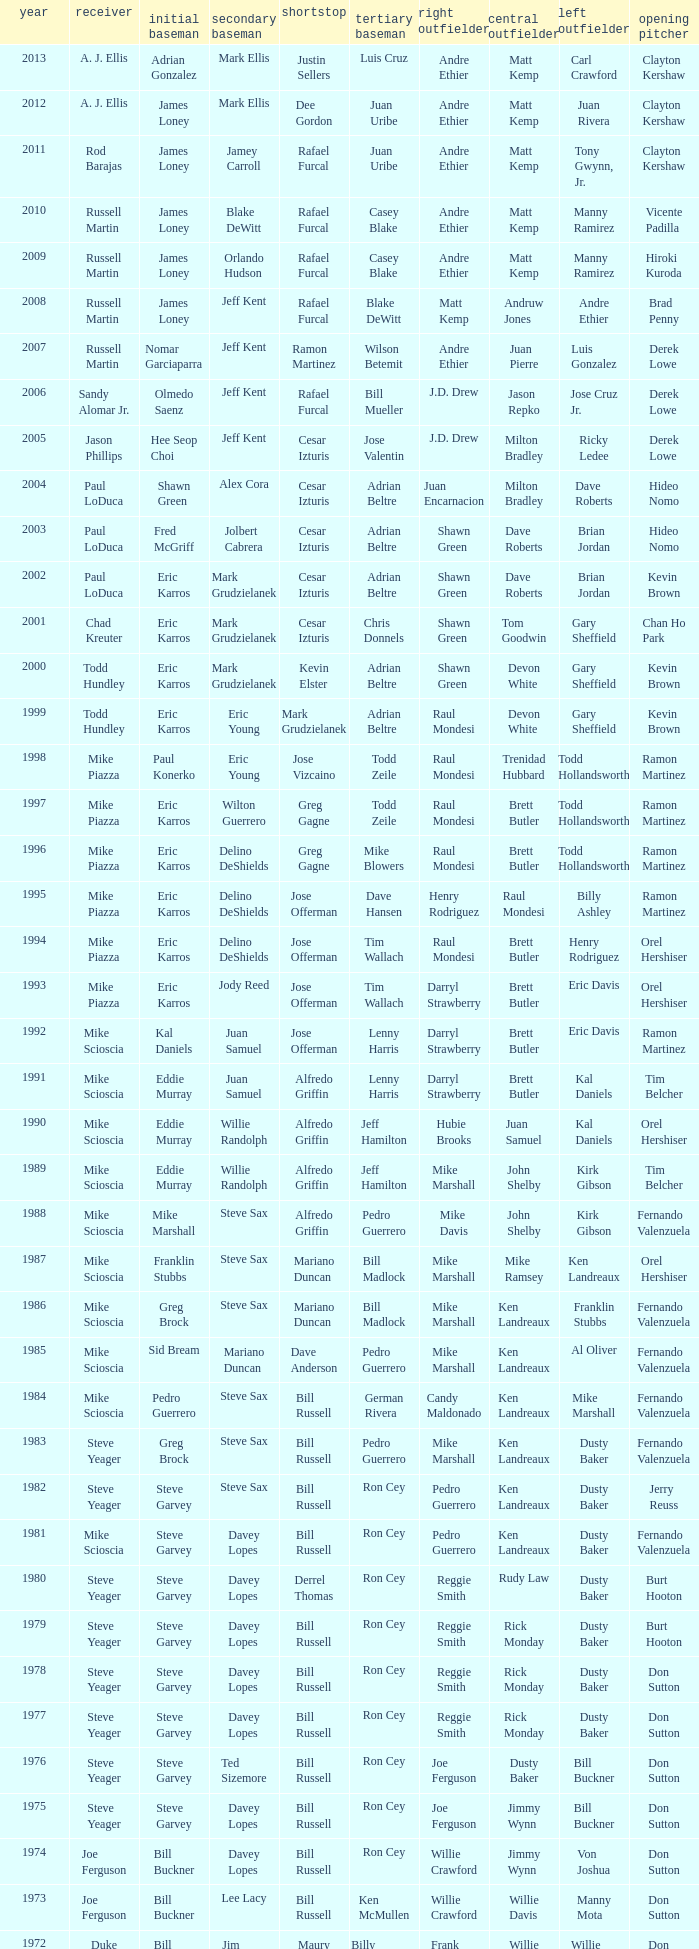Who played SS when paul konerko played 1st base? Jose Vizcaino. 